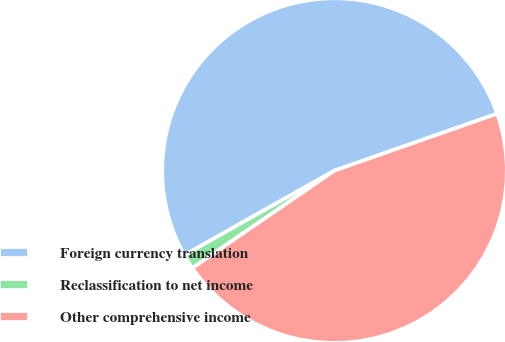<chart> <loc_0><loc_0><loc_500><loc_500><pie_chart><fcel>Foreign currency translation<fcel>Reclassification to net income<fcel>Other comprehensive income<nl><fcel>52.8%<fcel>1.4%<fcel>45.79%<nl></chart> 